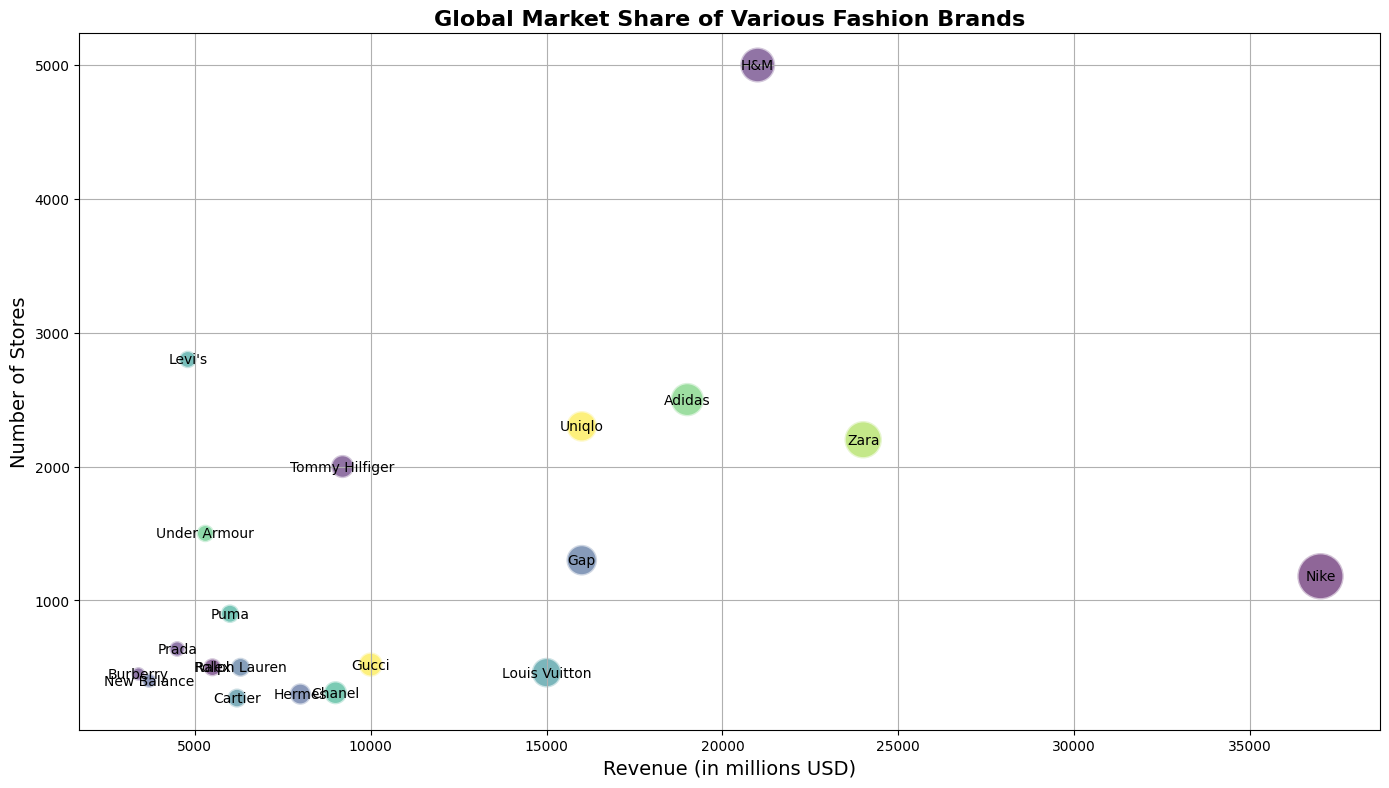Which brand has the highest revenue? Locate the bubble with the highest x-axis value representing revenue. The bubble positioned furthest to the right corresponds to the brand with the highest revenue, which is Nike.
Answer: Nike How many stores does Gucci have compared to Louis Vuitton? Find the positions of Gucci and Louis Vuitton on the y-axis. Gucci has fewer stores, indicated by a lower position on the y-axis. Gucci has 520 stores while Louis Vuitton has 460.
Answer: Gucci: 520, Louis Vuitton: 460 Which brand has the smallest market share and how many stores do they have? The smallest bubble, which represents the smallest market share, can be found visually. Burberry has the smallest market share and the information corresponding to this bubble indicates it has 450 stores.
Answer: Burberry: 450 stores Which brand has a higher market share, Adidas or Tommy Hilfiger? Compare the size of the bubbles corresponding to Adidas and Tommy Hilfiger. Larger bubbles represent higher market shares. Adidas has a larger bubble hence a higher market share than Tommy Hilfiger.
Answer: Adidas Between Nike and H&M, which brand has more stores? Locate the positions of Nike and H&M on the y-axis indicating the number of stores. H&M is higher on the y-axis, indicating it has more stores than Nike.
Answer: H&M What is the combined revenue of Uniqlo and Gap? Find the x-axis values representing the revenue of Uniqlo and Gap. Add these values: 16000 from Uniqlo + 16000 from Gap = 32000.
Answer: 32000 Which brand has more stores, Zara or Uniqlo? Compare the positions of Zara and Uniqlo on the y-axis representing the number of stores. Zara has 2200 stores, while Uniqlo has 2300 stores, so Uniqlo has more stores.
Answer: Uniqlo Rank Nike, Louis Vuitton, and Adidas by their market share from highest to lowest. Order the sizes of the bubbles representing Nike, Louis Vuitton, and Adidas. Nike has the largest bubble, followed by Adidas and then Louis Vuitton.
Answer: Nike > Adidas > Louis Vuitton Which brand has fewer stores but a higher market share than Ralph Lauren? Identify bubbles representing brands with fewer stores (lower on the y-axis) but larger in size (market share) than Ralph Lauren. Louis Vuitton fits this description with 460 stores and a higher market share of 4.6 compared to Ralph Lauren's 500 stores and 1.9 market share.
Answer: Louis Vuitton 